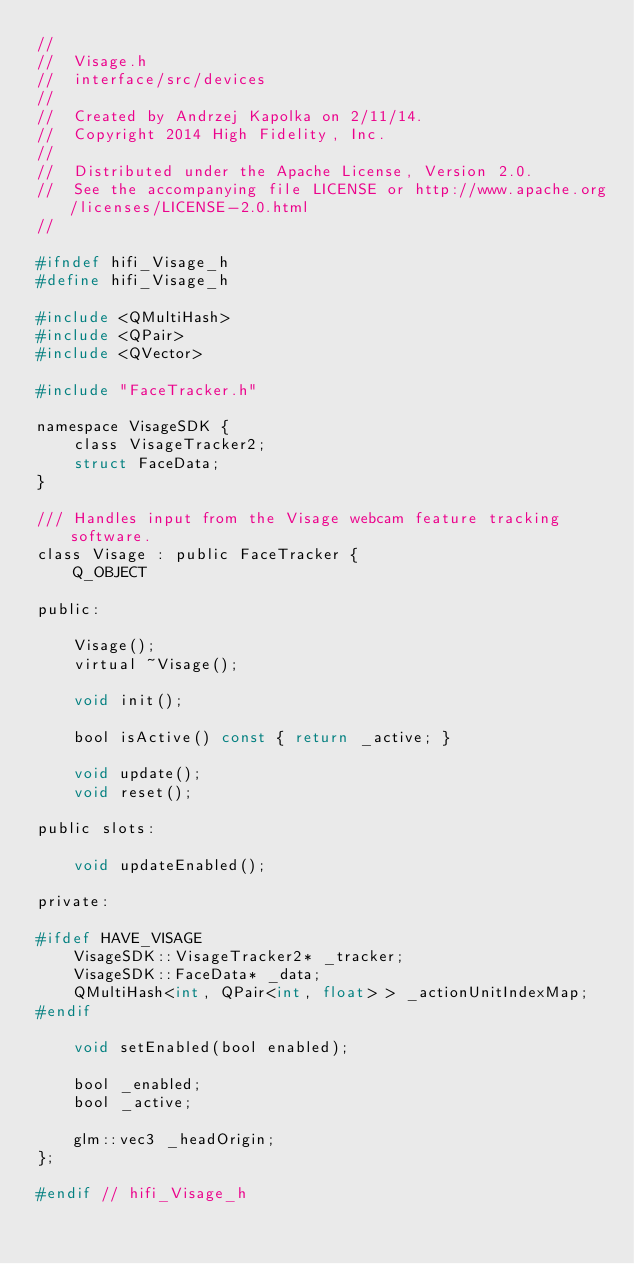<code> <loc_0><loc_0><loc_500><loc_500><_C_>//
//  Visage.h
//  interface/src/devices
//
//  Created by Andrzej Kapolka on 2/11/14.
//  Copyright 2014 High Fidelity, Inc.
//
//  Distributed under the Apache License, Version 2.0.
//  See the accompanying file LICENSE or http://www.apache.org/licenses/LICENSE-2.0.html
//

#ifndef hifi_Visage_h
#define hifi_Visage_h

#include <QMultiHash>
#include <QPair>
#include <QVector>

#include "FaceTracker.h"

namespace VisageSDK {
    class VisageTracker2;
    struct FaceData;
}

/// Handles input from the Visage webcam feature tracking software.
class Visage : public FaceTracker {
    Q_OBJECT
    
public:
    
    Visage();
    virtual ~Visage();
    
    void init();
    
    bool isActive() const { return _active; }
    
    void update();
    void reset();

public slots:

    void updateEnabled();
    
private:

#ifdef HAVE_VISAGE
    VisageSDK::VisageTracker2* _tracker;
    VisageSDK::FaceData* _data;
    QMultiHash<int, QPair<int, float> > _actionUnitIndexMap; 
#endif
    
    void setEnabled(bool enabled);
    
    bool _enabled;
    bool _active;

    glm::vec3 _headOrigin;
};

#endif // hifi_Visage_h
</code> 